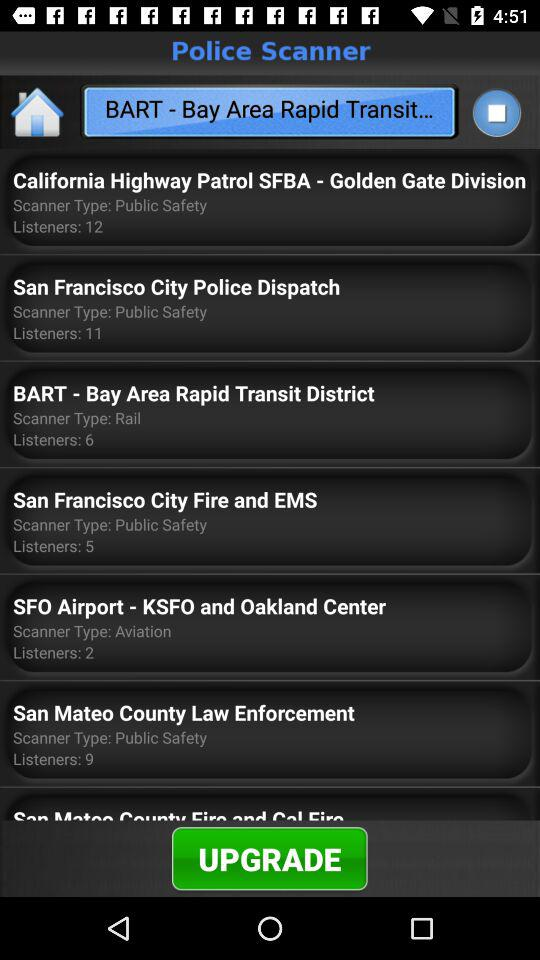What is the scanner type for "San Francisco City Fire and EMS"? The scanner type for "San Francisco City Fire and EMS" is "Public Safety". 